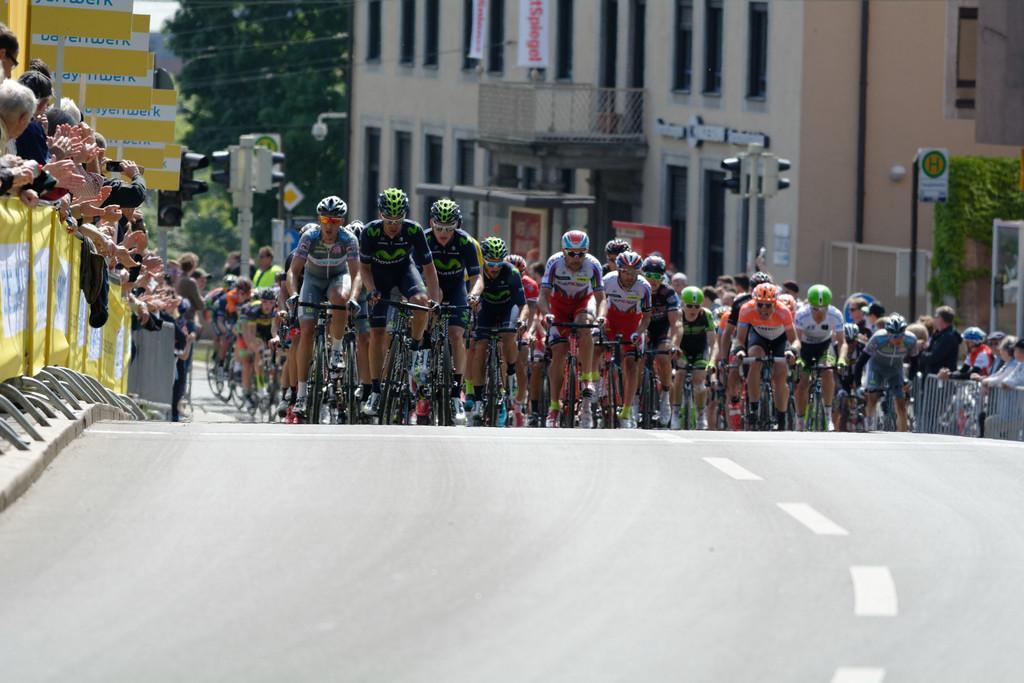Describe this image in one or two sentences. In this picture I can see so many people riding bicycle on the roadside few people are standing and taking pictures, behind there are some buildings. 